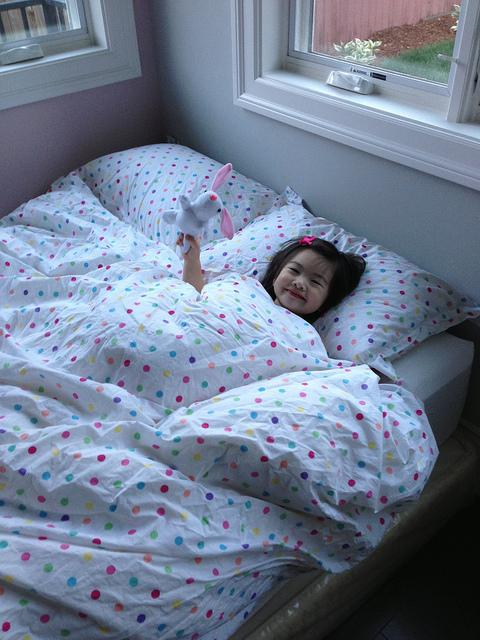Who is in the bed? little girl 